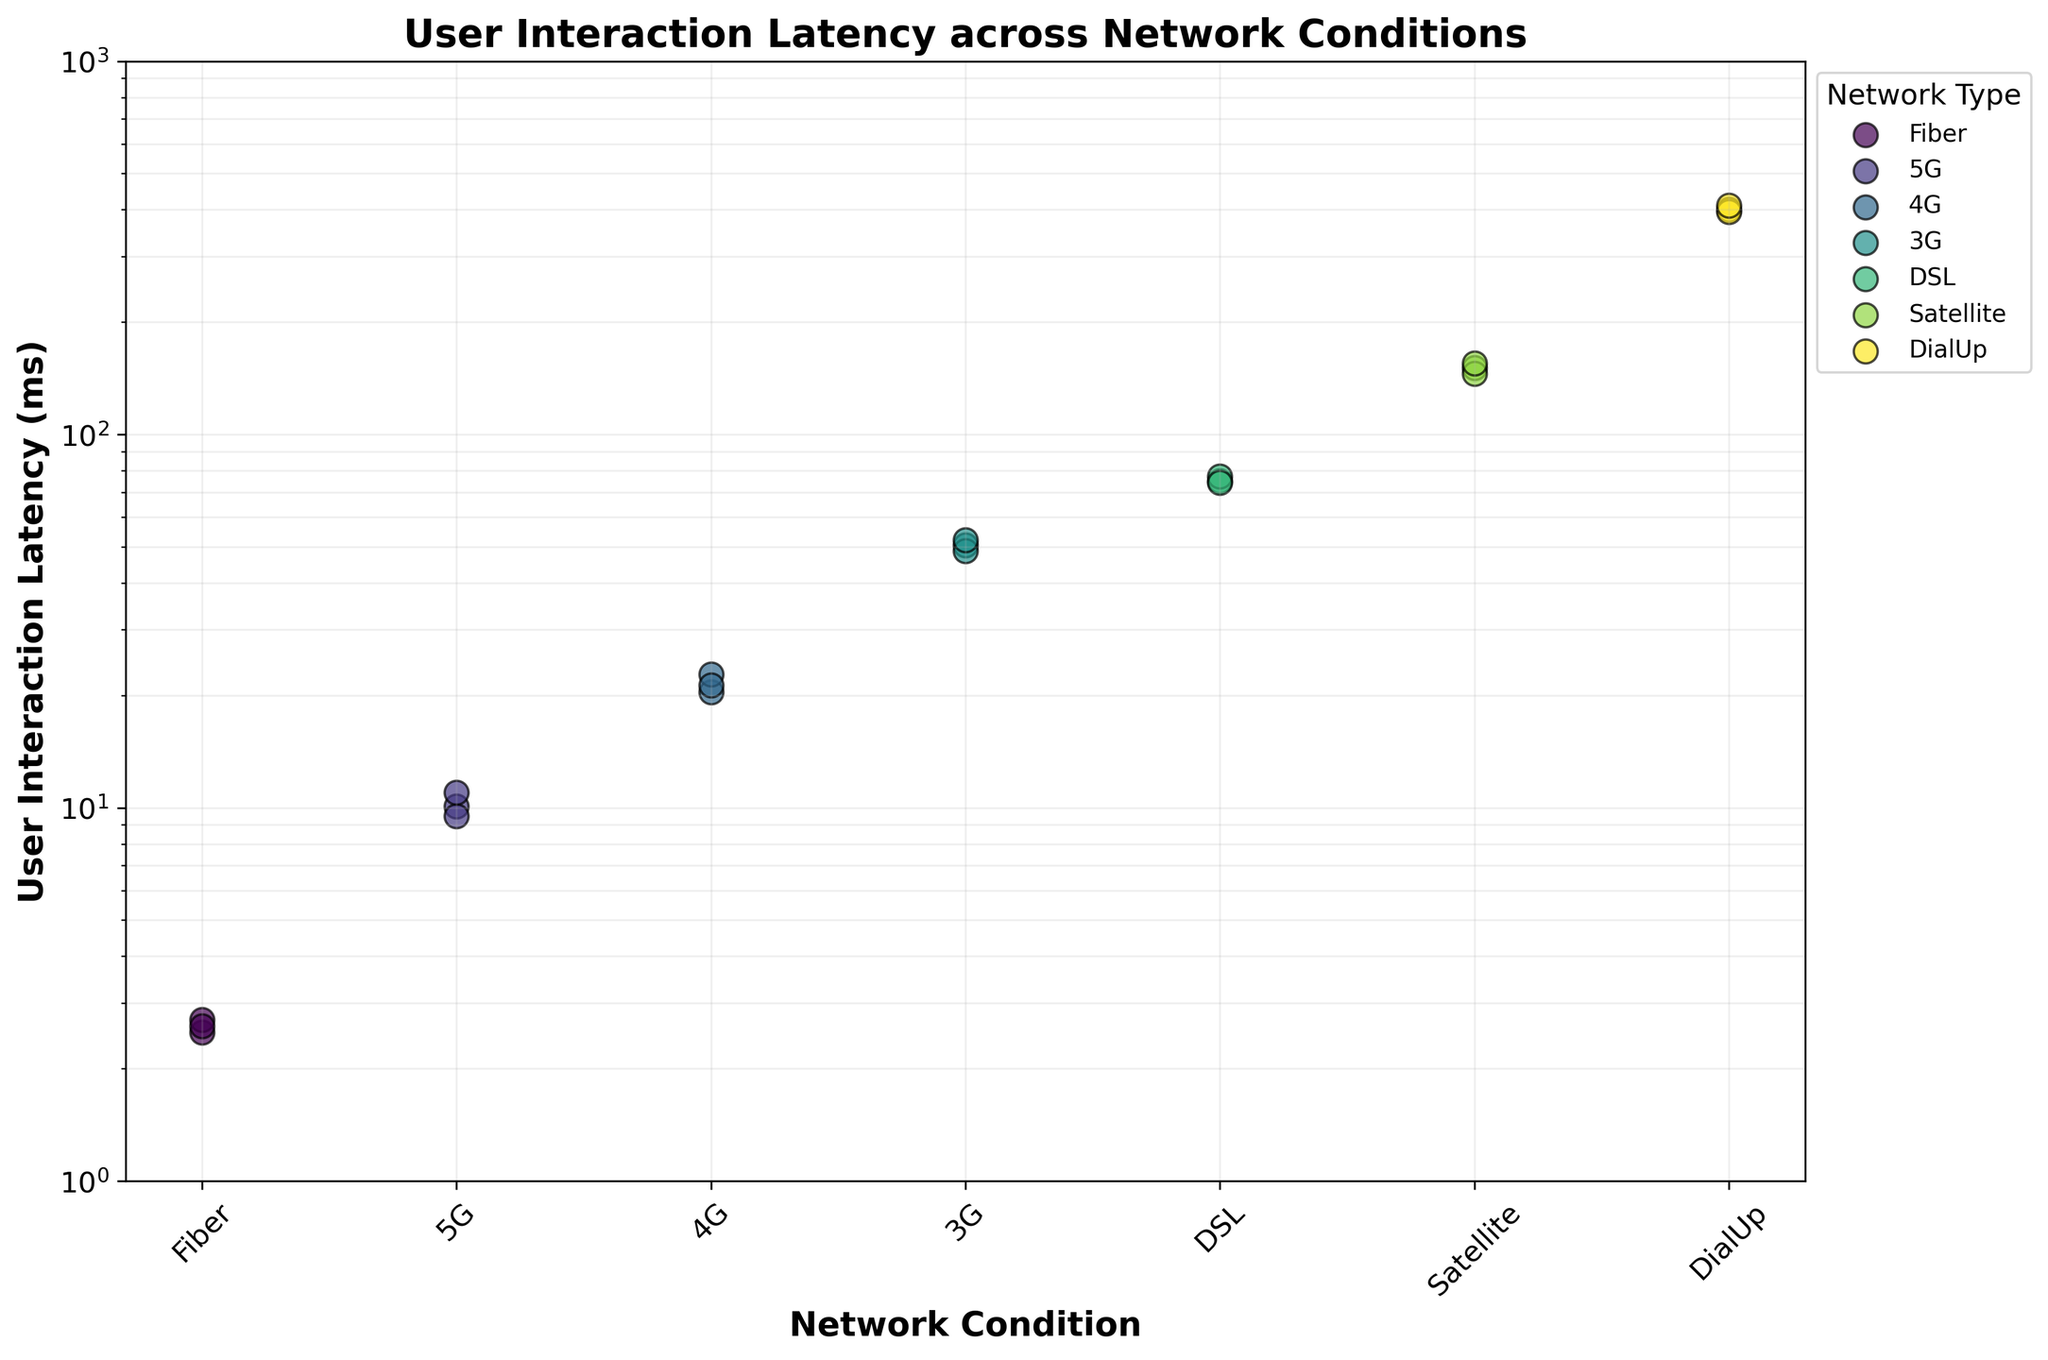Which network condition has the lowest user interaction latency? The marker for the `Fiber` network condition has the lowest Y-axis values, near the bottom of the plot.
Answer: Fiber How many data points are there for the 5G network condition? There are three distinct scatter points for `5G` visible on the plot.
Answer: 3 Is the user interaction latency for DialUp greater than for Satellite? The Y-axis position of DialUp points is higher than that of Satellite points, indicating greater latencies.
Answer: Yes What is the range of user interaction latency for 3G? The lowest 3G latency is around 48.7 ms, and the highest is about 52.1 ms. Subtract the smallest from the largest value to get the range: 52.1 - 48.7.
Answer: 3.4 ms Which network condition has the highest variability in user interaction latency? The `DialUp` points are spread the most vertically (along the Y-axis), indicating high variability.
Answer: DialUp What is the median user interaction latency for Fiber? The points for Fiber are 2.5, 2.6, and 2.7. The median is the middle value: 2.6 ms.
Answer: 2.6 ms Compare the latency between 4G and 5G. Which has higher values? The markers for `4G` are higher on the Y-axis compared to those for `5G`, indicating higher latencies.
Answer: 4G Does the user interaction latency show a consistent increase from Fiber to DialUp? The scatter points increase in Y-axis value from left to right, indicating that latency increases from Fiber to DialUp.
Answer: Yes Are all the latencies for the `DSL` network condition within the same order of magnitude? The `DSL` points are all grouped around the same Y-axis value range (70-80 ms) and do not span multiple orders of magnitude.
Answer: Yes What is the log scale range for user interaction latency shown on the plot? The Y-axis shows values starting from 1 and going up to 1000 ms, representing the log scale range.
Answer: 1 to 1000 ms 